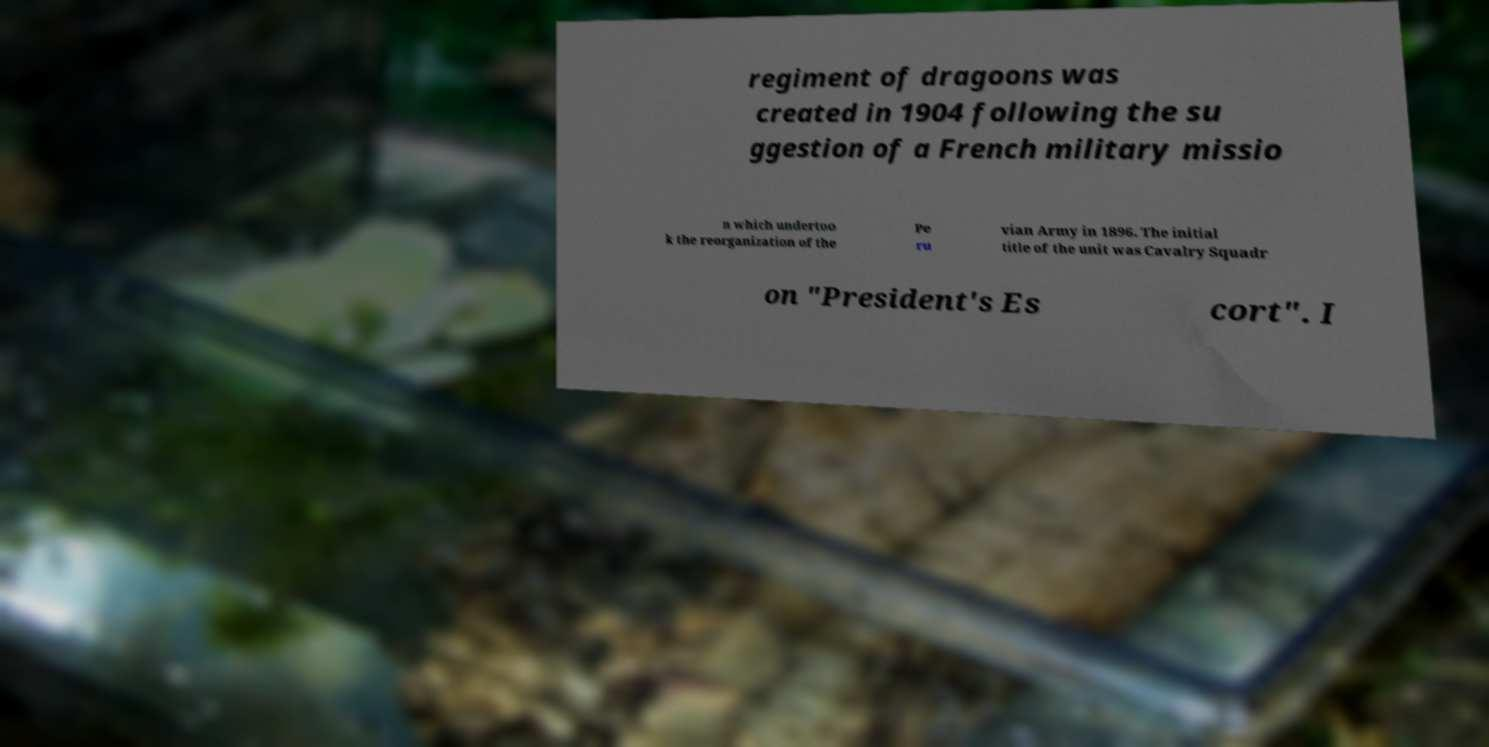Please identify and transcribe the text found in this image. regiment of dragoons was created in 1904 following the su ggestion of a French military missio n which undertoo k the reorganization of the Pe ru vian Army in 1896. The initial title of the unit was Cavalry Squadr on "President's Es cort". I 